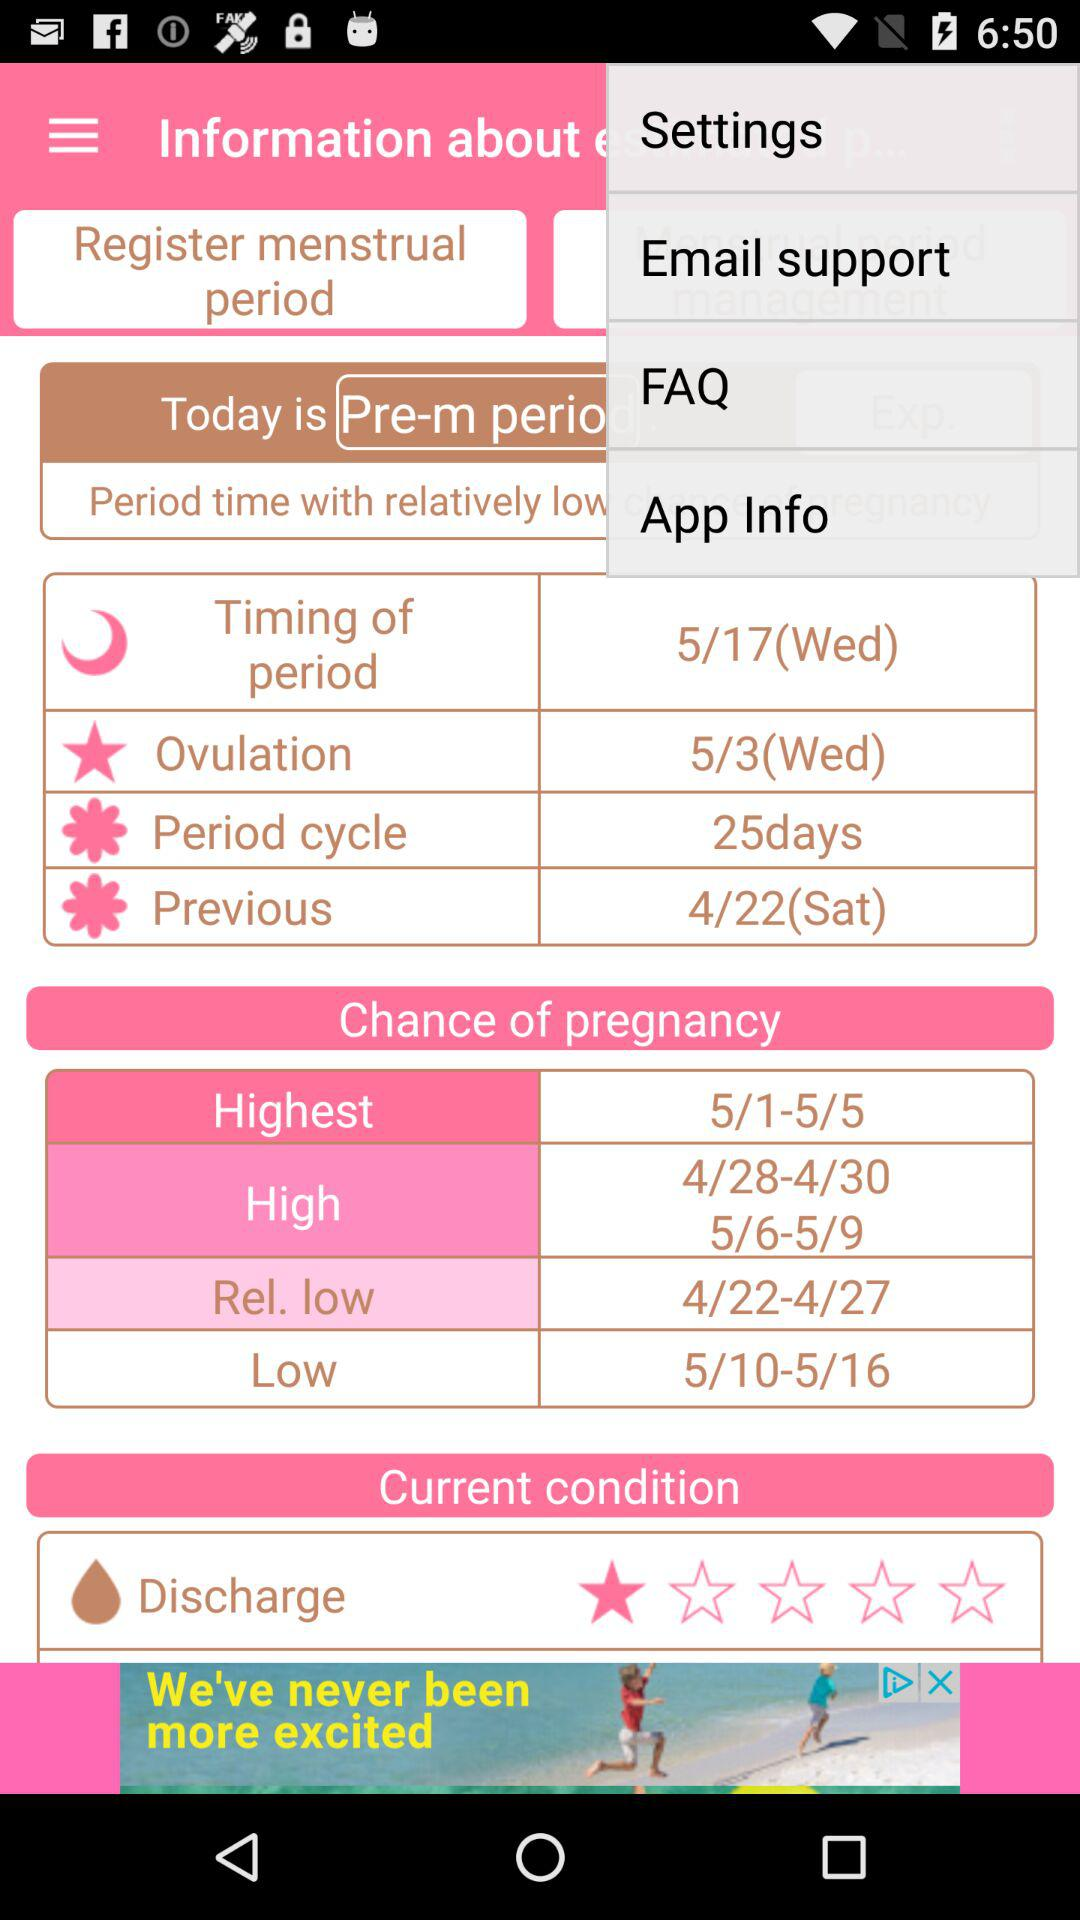What is the date of ovulation? The date of ovulation is Wednesday, May 3. 